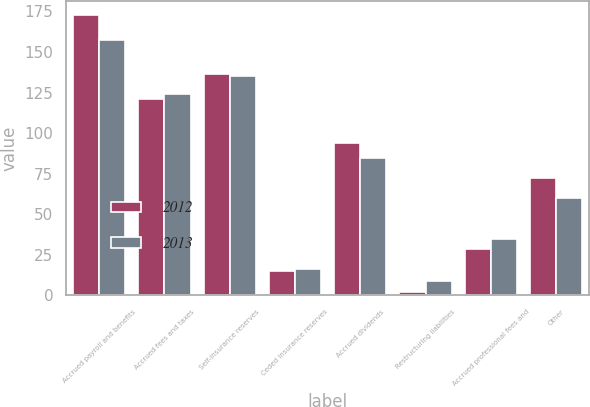Convert chart. <chart><loc_0><loc_0><loc_500><loc_500><stacked_bar_chart><ecel><fcel>Accrued payroll and benefits<fcel>Accrued fees and taxes<fcel>Self-insurance reserves<fcel>Ceded insurance reserves<fcel>Accrued dividends<fcel>Restructuring liabilities<fcel>Accrued professional fees and<fcel>Other<nl><fcel>2012<fcel>172.7<fcel>121.3<fcel>136.6<fcel>14.8<fcel>93.7<fcel>1.8<fcel>28.3<fcel>72.1<nl><fcel>2013<fcel>157.1<fcel>124.2<fcel>135.5<fcel>16.2<fcel>84.9<fcel>9<fcel>34.6<fcel>60<nl></chart> 